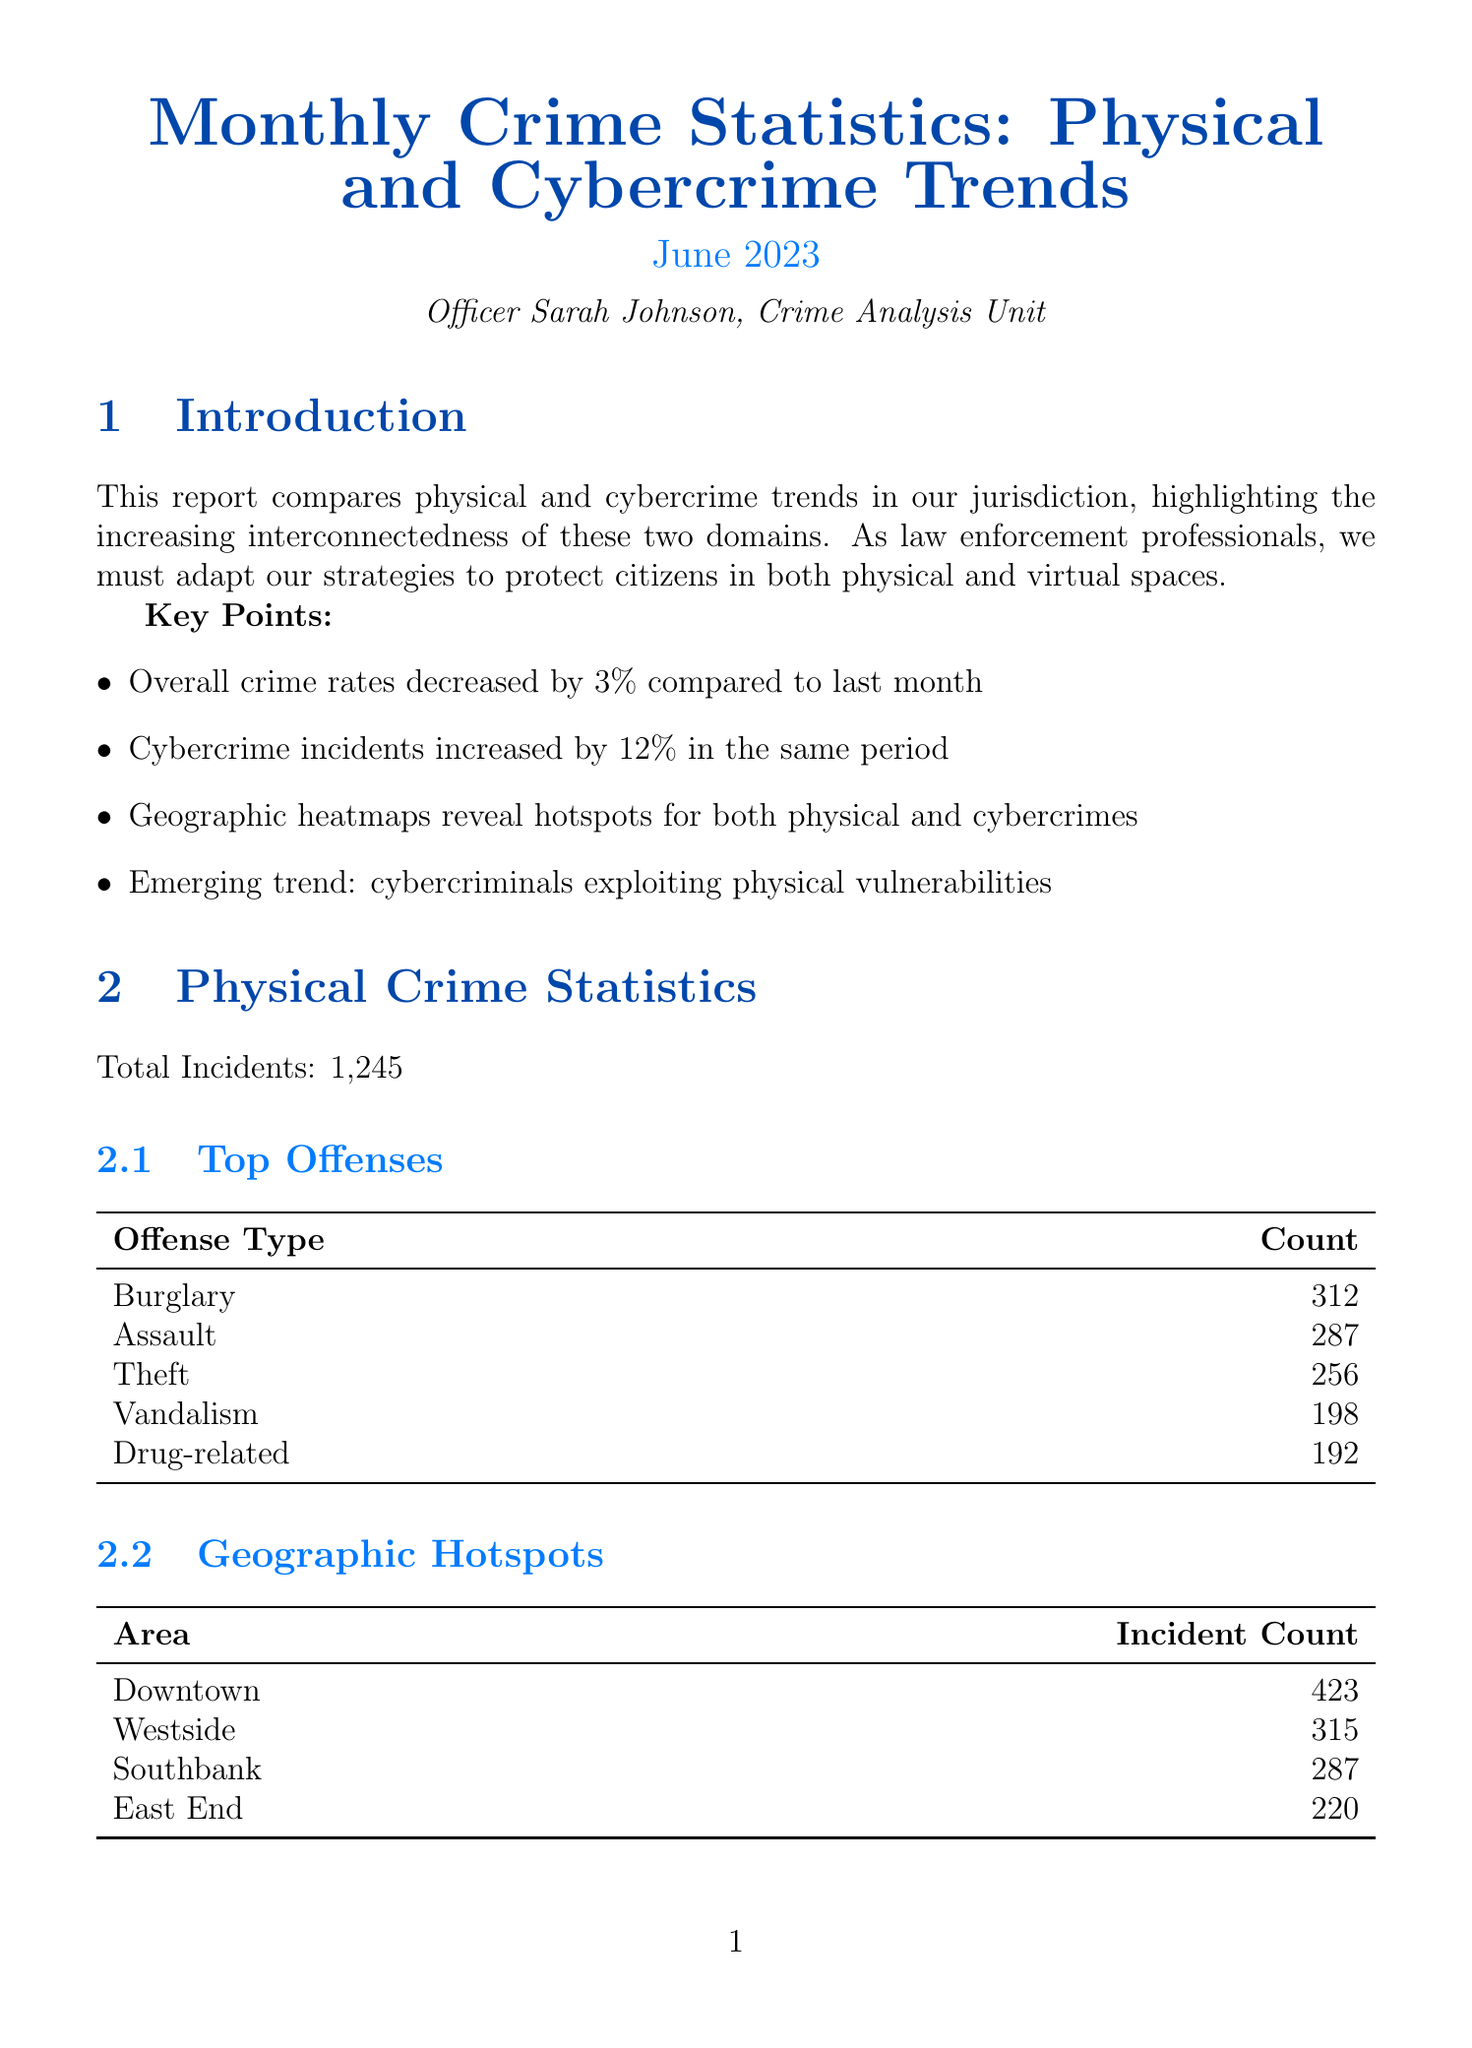What is the report title? The report title is found at the beginning of the document.
Answer: Monthly Crime Statistics: Physical and Cybercrime Trends What is the total number of physical crime incidents reported? The total number of physical crime incidents is specifically listed in the document.
Answer: 1245 What was the percentage increase in cybercrime incidents? The percentage increase is mentioned as a key point in the introduction section.
Answer: 12% Which area had the highest number of physical crime incidents? The area with the highest incident count is shown in the geographic hotspots section for physical crimes.
Answer: Downtown What is one emerging trend mentioned in the report? The emerging trends are highlighted in a specific section of the document.
Answer: Cybercriminals exploiting physical vulnerabilities How many top offenses are listed for cybercrime? The number of top offenses can be counted from the subsection that lists them under cybercrime statistics.
Answer: 5 What strategy involves cross-training officers? This strategy is specified in the law enforcement response strategies section.
Answer: Integrated What is a recommendation for the department? Recommendations are listed towards the end of the document.
Answer: Invest in advanced cybersecurity tools for the department What was the change in violent crimes percentage? The change in violent crimes is mentioned in the trend analysis section for physical crime.
Answer: Decrease in violent crimes by 5% 